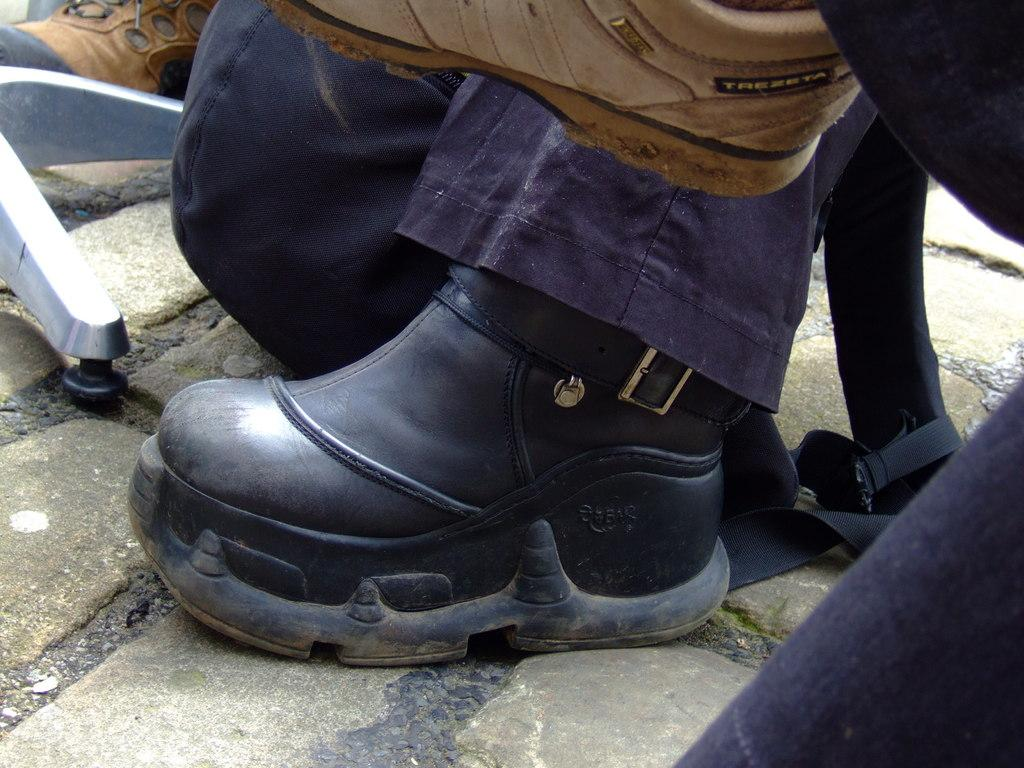What type of footwear is visible in the image? There are boots in the image. What is the surface on which the boots are placed? The ground is visible in the image. What object can be seen on the ground near the boots? There is a bag on the ground in the image. What type of fruit is being read by the boots in the image? There is no fruit or reading depicted in the image; it features boots and a bag on the ground. 